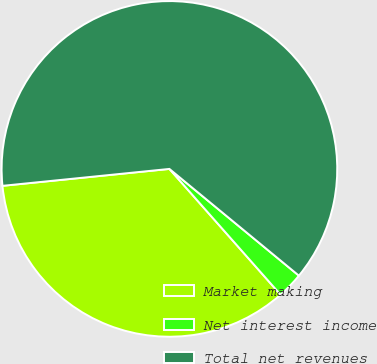Convert chart to OTSL. <chart><loc_0><loc_0><loc_500><loc_500><pie_chart><fcel>Market making<fcel>Net interest income<fcel>Total net revenues<nl><fcel>34.91%<fcel>2.51%<fcel>62.58%<nl></chart> 